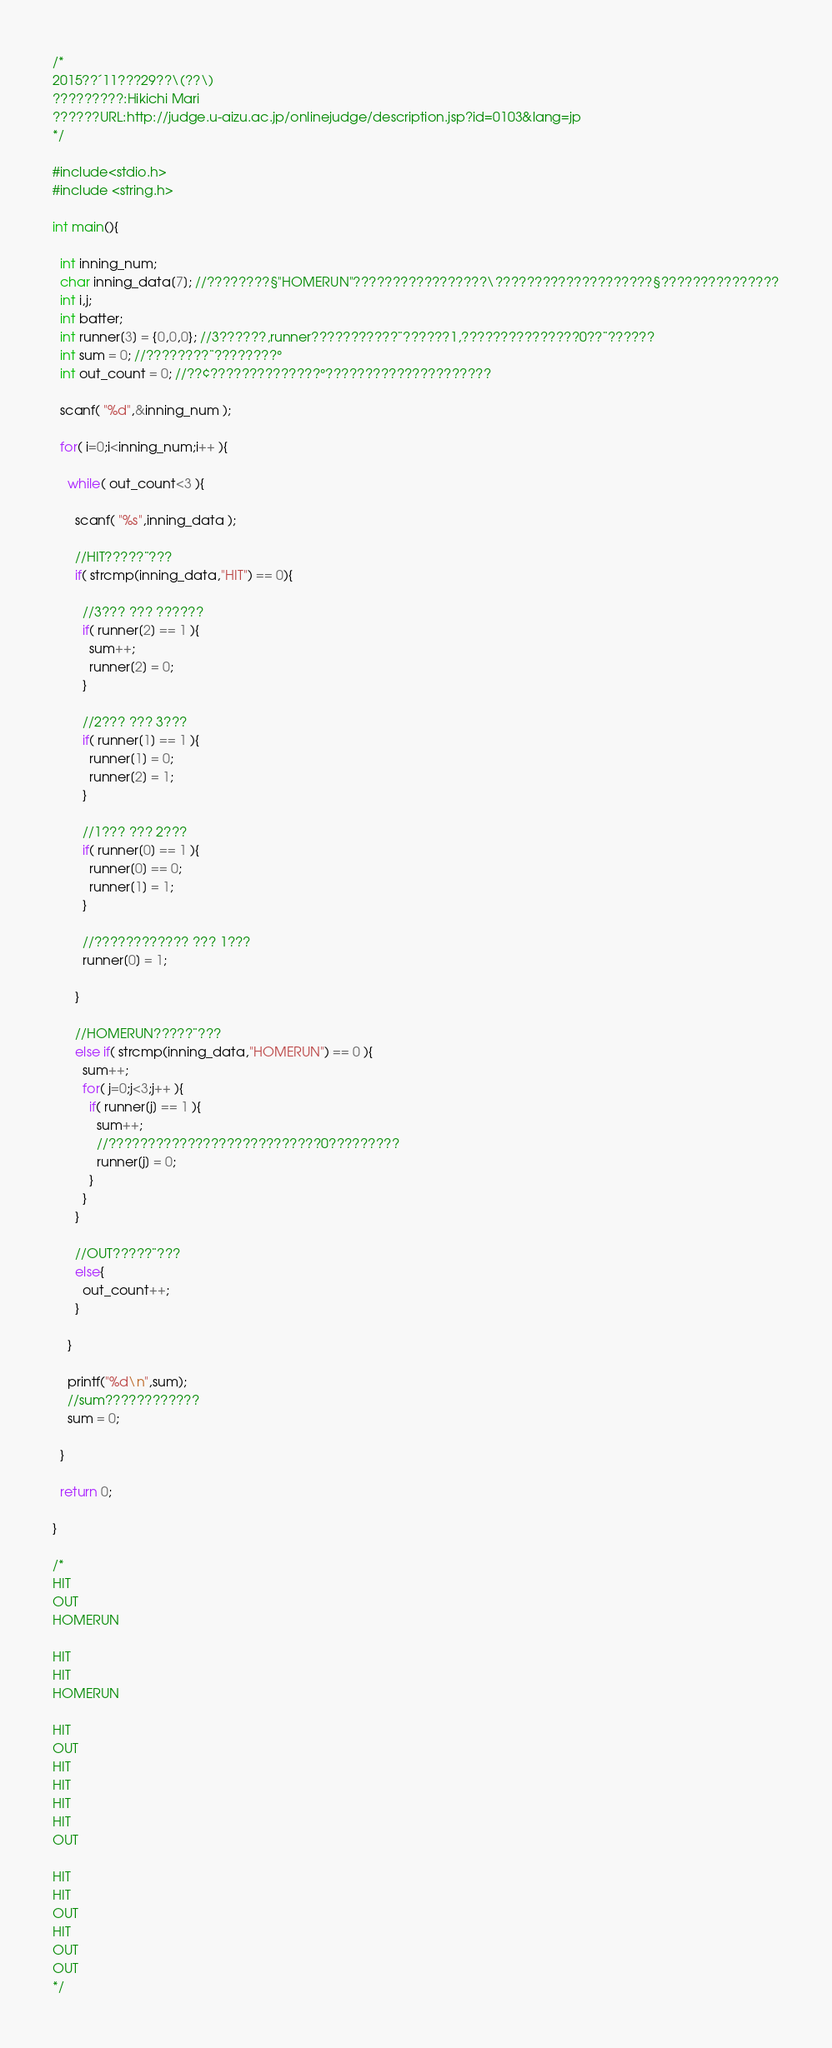<code> <loc_0><loc_0><loc_500><loc_500><_C_>/*
2015??´11???29??\(??\)
?????????:Hikichi Mari
??????URL:http://judge.u-aizu.ac.jp/onlinejudge/description.jsp?id=0103&lang=jp
*/

#include<stdio.h>
#include <string.h>

int main(){

  int inning_num;
  char inning_data[7]; //????????§"HOMERUN"?????????????????\????????????????????§???????????????
  int i,j;
  int batter;
  int runner[3] = {0,0,0}; //3??????,runner???????????¨??????1,???????????????0??¨??????
  int sum = 0; //????????¨????????°
  int out_count = 0; //??¢??????????????°?????????????????????

  scanf( "%d",&inning_num );

  for( i=0;i<inning_num;i++ ){

    while( out_count<3 ){

      scanf( "%s",inning_data );

      //HIT?????¨???
      if( strcmp(inning_data,"HIT") == 0){

        //3??? ??? ??????
        if( runner[2] == 1 ){
          sum++;
          runner[2] = 0;
        }

        //2??? ??? 3???
        if( runner[1] == 1 ){
          runner[1] = 0;
          runner[2] = 1;
        }

        //1??? ??? 2???
        if( runner[0] == 1 ){
          runner[0] == 0;
          runner[1] = 1;
        }

        //???????????? ??? 1???
        runner[0] = 1;

      }

      //HOMERUN?????¨???
      else if( strcmp(inning_data,"HOMERUN") == 0 ){
        sum++;
        for( j=0;j<3;j++ ){
          if( runner[j] == 1 ){
            sum++;
            //???????????????????????????0?????????
            runner[j] = 0;
          }
        }
      }

      //OUT?????¨???
      else{
        out_count++;
      }

    }

    printf("%d\n",sum);
    //sum????????????
    sum = 0;

  }

  return 0;

}

/*
HIT
OUT
HOMERUN

HIT
HIT
HOMERUN

HIT
OUT
HIT
HIT
HIT
HIT
OUT

HIT
HIT
OUT
HIT
OUT
OUT
*/</code> 